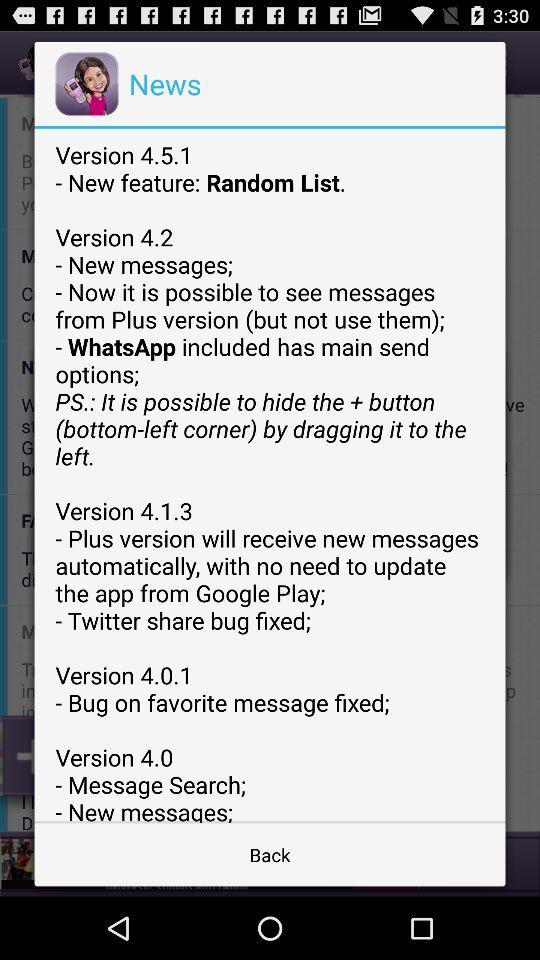What is the new feature in version 4.0.1? The new feature in version 4.0.1 is "Bug on favorite message fixed". 